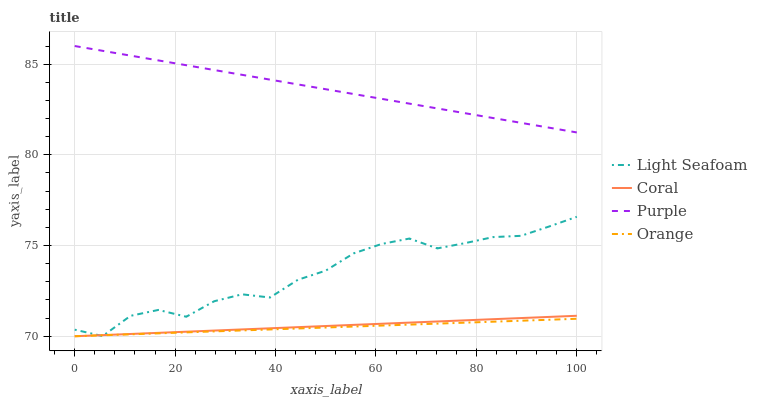Does Orange have the minimum area under the curve?
Answer yes or no. Yes. Does Purple have the maximum area under the curve?
Answer yes or no. Yes. Does Coral have the minimum area under the curve?
Answer yes or no. No. Does Coral have the maximum area under the curve?
Answer yes or no. No. Is Coral the smoothest?
Answer yes or no. Yes. Is Light Seafoam the roughest?
Answer yes or no. Yes. Is Orange the smoothest?
Answer yes or no. No. Is Orange the roughest?
Answer yes or no. No. Does Orange have the lowest value?
Answer yes or no. Yes. Does Light Seafoam have the lowest value?
Answer yes or no. No. Does Purple have the highest value?
Answer yes or no. Yes. Does Coral have the highest value?
Answer yes or no. No. Is Orange less than Purple?
Answer yes or no. Yes. Is Purple greater than Light Seafoam?
Answer yes or no. Yes. Does Coral intersect Light Seafoam?
Answer yes or no. Yes. Is Coral less than Light Seafoam?
Answer yes or no. No. Is Coral greater than Light Seafoam?
Answer yes or no. No. Does Orange intersect Purple?
Answer yes or no. No. 